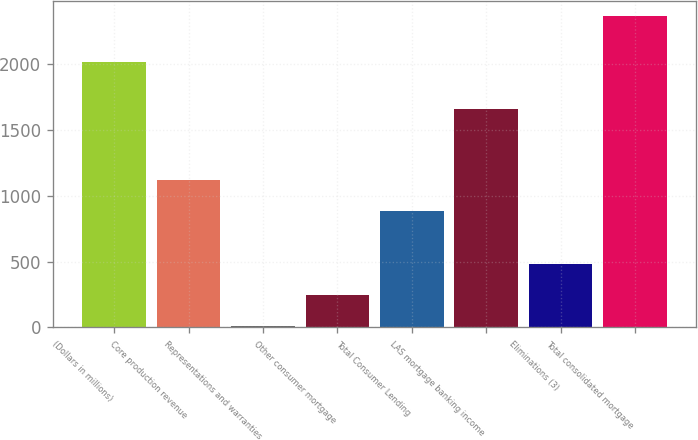Convert chart. <chart><loc_0><loc_0><loc_500><loc_500><bar_chart><fcel>(Dollars in millions)<fcel>Core production revenue<fcel>Representations and warranties<fcel>Other consumer mortgage<fcel>Total Consumer Lending<fcel>LAS mortgage banking income<fcel>Eliminations (3)<fcel>Total consolidated mortgage<nl><fcel>2015<fcel>1118.3<fcel>11<fcel>246.3<fcel>883<fcel>1658<fcel>481.6<fcel>2364<nl></chart> 